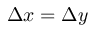Convert formula to latex. <formula><loc_0><loc_0><loc_500><loc_500>\Delta x = \Delta y</formula> 